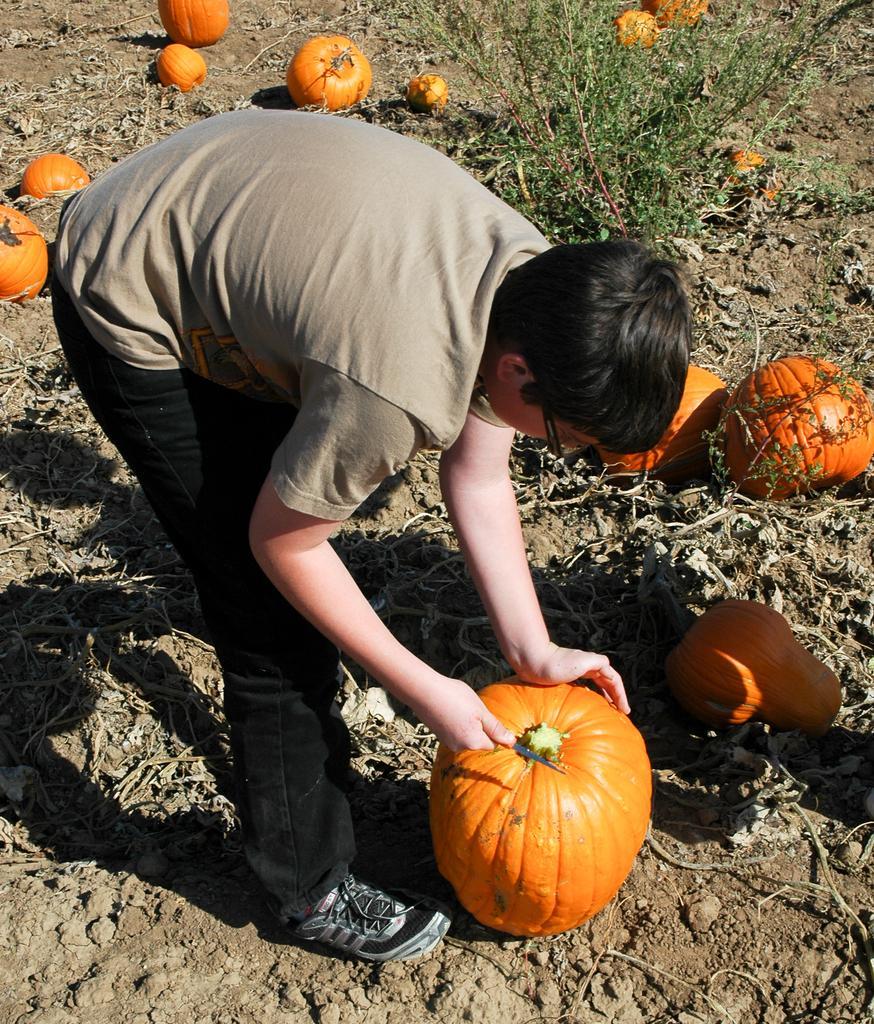Can you describe this image briefly? In this picture I can see a person standing and holding a knife and a pumpkin, and in the background there are pumpkins and a plant. 